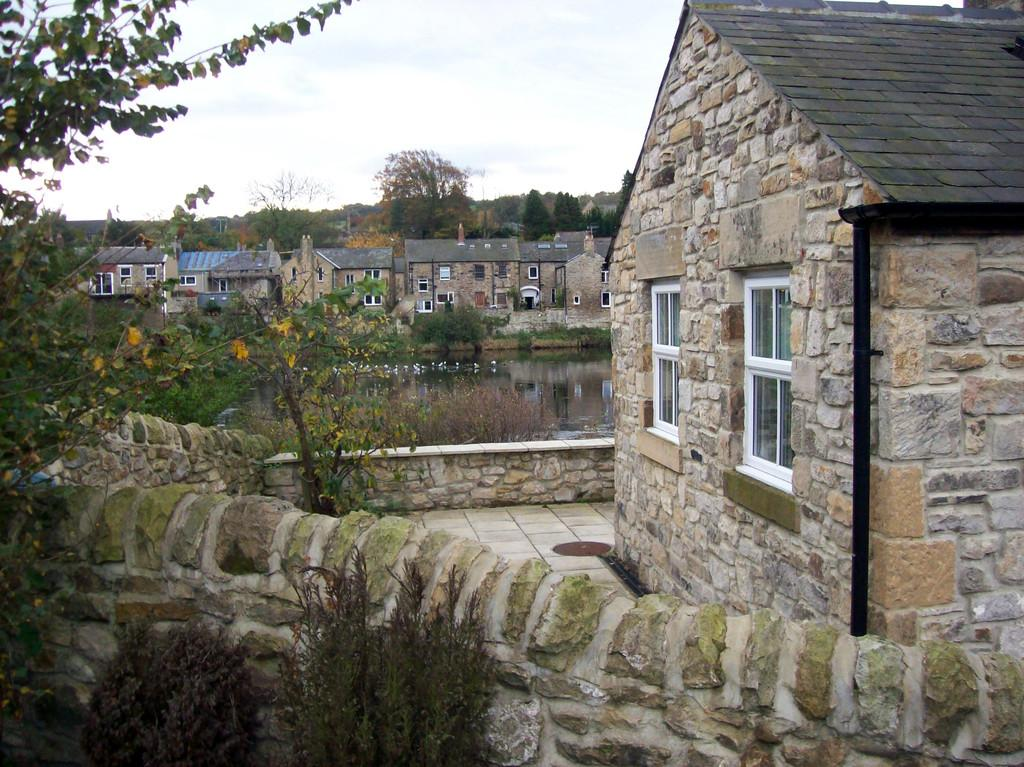What type of structures are present in the image? There are houses with roofs and windows in the image. What kind of vegetation can be seen in the image? There are plants with flowers and a group of trees in the image. What natural element is visible in the image? There is water visible in the image. How would you describe the sky in the image? The sky is cloudy in the image. How many hands are visible in the image? There are no hands visible in the image. 